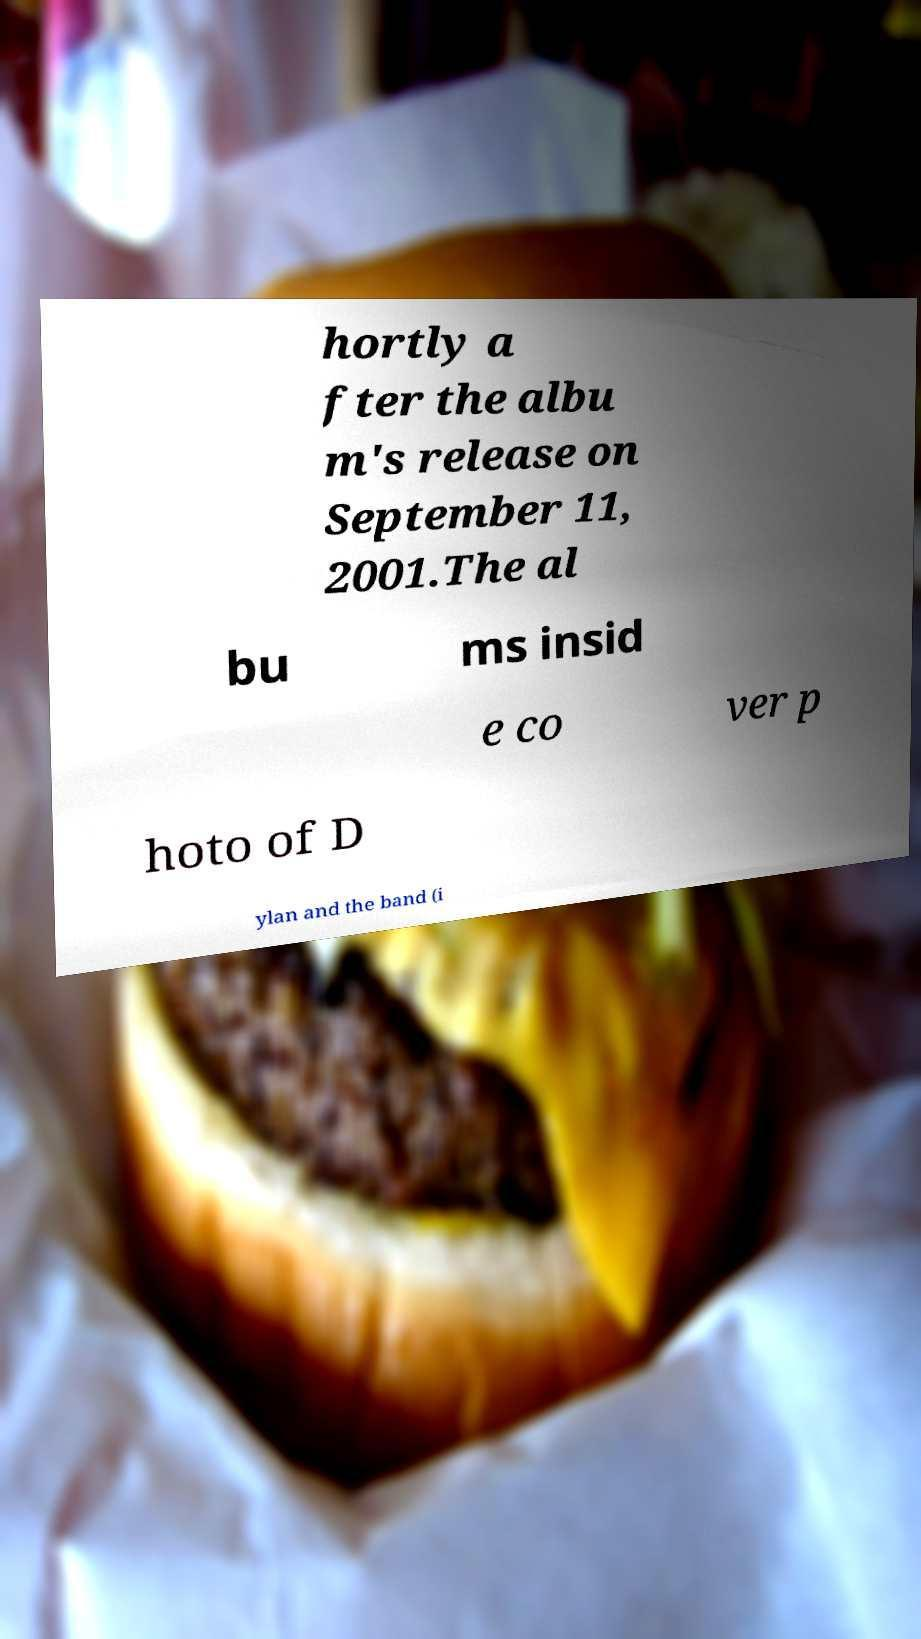Can you read and provide the text displayed in the image?This photo seems to have some interesting text. Can you extract and type it out for me? hortly a fter the albu m's release on September 11, 2001.The al bu ms insid e co ver p hoto of D ylan and the band (i 